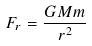<formula> <loc_0><loc_0><loc_500><loc_500>F _ { r } = \frac { G M m } { r ^ { 2 } }</formula> 